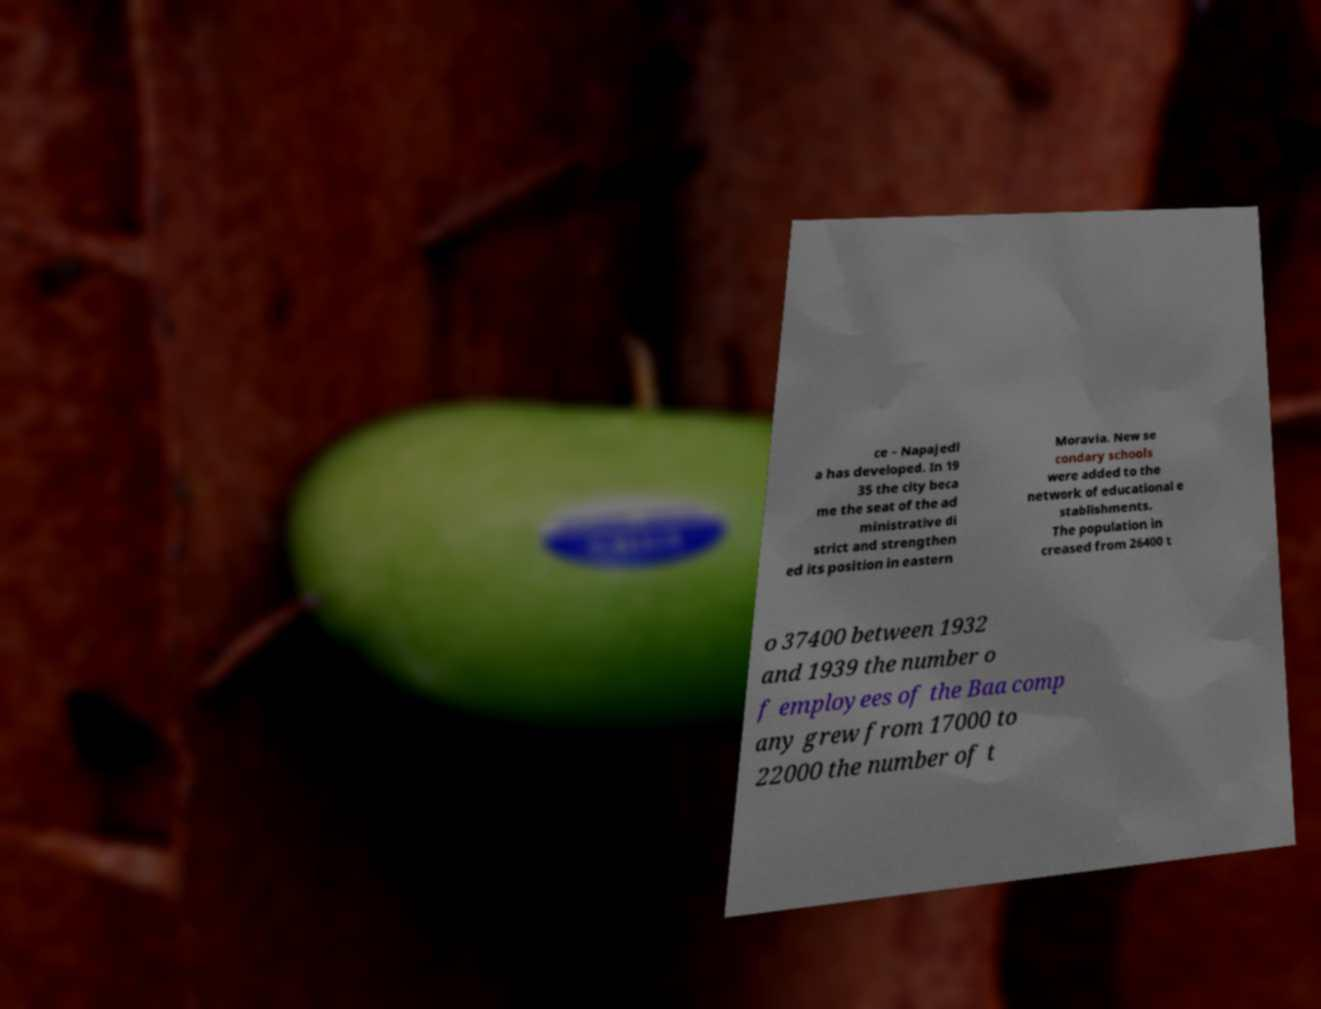I need the written content from this picture converted into text. Can you do that? ce – Napajedl a has developed. In 19 35 the city beca me the seat of the ad ministrative di strict and strengthen ed its position in eastern Moravia. New se condary schools were added to the network of educational e stablishments. The population in creased from 26400 t o 37400 between 1932 and 1939 the number o f employees of the Baa comp any grew from 17000 to 22000 the number of t 